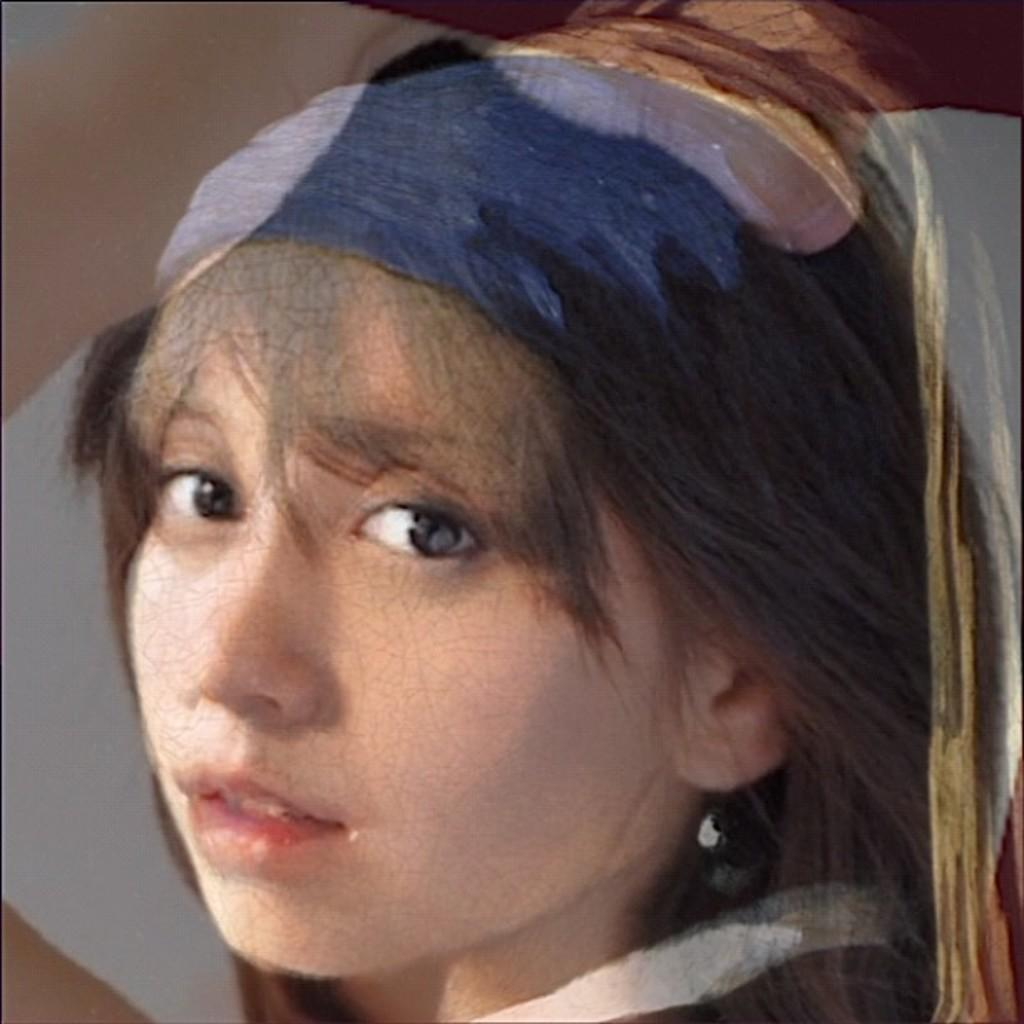How was the image altered or modified? The image is edited, which means it has been altered or modified in some way. What is the main subject of the image? There is a woman's face in the image. How many frogs can be seen in the image? There are no frogs present in the image; it features a woman's face. What type of loaf is the woman cooking in the image? There is no cooking or loaf present in the image; it only shows a woman's face. 